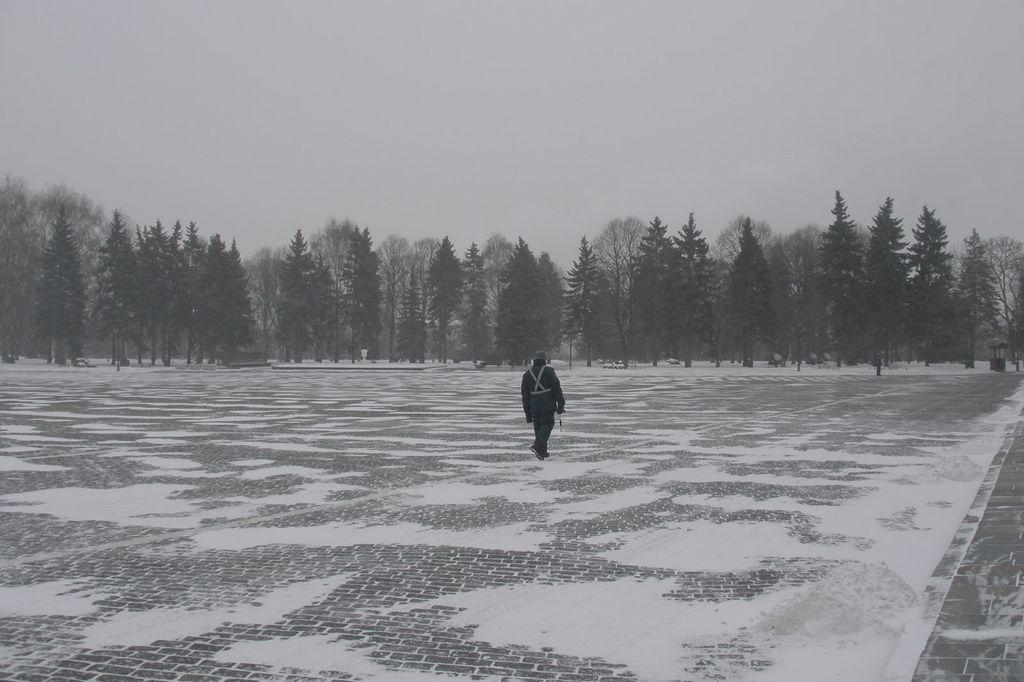What can be seen in the image? There is a person in the image. What is the person doing in the image? The person is holding an object. What is the condition of the ground in the image? The ground is covered with snow. What feature is present on the right side of the image? There is a path on the right side of the image. What part of the natural environment is visible in the image? The sky is visible in the image. Can you see any wounds on the person in the image? There is no indication of any wounds on the person in the image. What type of pen is the person using to write in the image? There is no pen present in the image, and the person is not writing. 